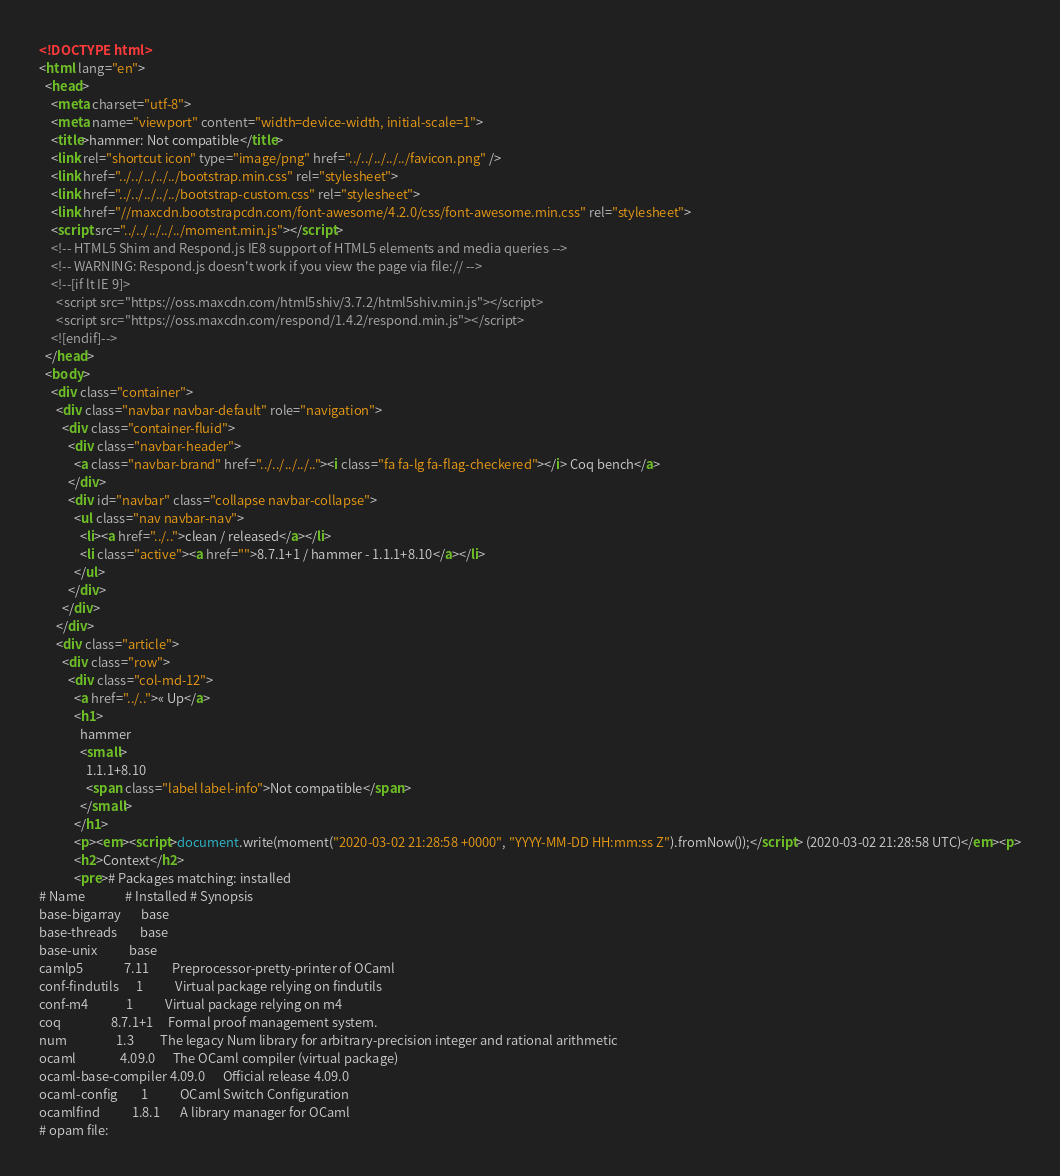<code> <loc_0><loc_0><loc_500><loc_500><_HTML_><!DOCTYPE html>
<html lang="en">
  <head>
    <meta charset="utf-8">
    <meta name="viewport" content="width=device-width, initial-scale=1">
    <title>hammer: Not compatible</title>
    <link rel="shortcut icon" type="image/png" href="../../../../../favicon.png" />
    <link href="../../../../../bootstrap.min.css" rel="stylesheet">
    <link href="../../../../../bootstrap-custom.css" rel="stylesheet">
    <link href="//maxcdn.bootstrapcdn.com/font-awesome/4.2.0/css/font-awesome.min.css" rel="stylesheet">
    <script src="../../../../../moment.min.js"></script>
    <!-- HTML5 Shim and Respond.js IE8 support of HTML5 elements and media queries -->
    <!-- WARNING: Respond.js doesn't work if you view the page via file:// -->
    <!--[if lt IE 9]>
      <script src="https://oss.maxcdn.com/html5shiv/3.7.2/html5shiv.min.js"></script>
      <script src="https://oss.maxcdn.com/respond/1.4.2/respond.min.js"></script>
    <![endif]-->
  </head>
  <body>
    <div class="container">
      <div class="navbar navbar-default" role="navigation">
        <div class="container-fluid">
          <div class="navbar-header">
            <a class="navbar-brand" href="../../../../.."><i class="fa fa-lg fa-flag-checkered"></i> Coq bench</a>
          </div>
          <div id="navbar" class="collapse navbar-collapse">
            <ul class="nav navbar-nav">
              <li><a href="../..">clean / released</a></li>
              <li class="active"><a href="">8.7.1+1 / hammer - 1.1.1+8.10</a></li>
            </ul>
          </div>
        </div>
      </div>
      <div class="article">
        <div class="row">
          <div class="col-md-12">
            <a href="../..">« Up</a>
            <h1>
              hammer
              <small>
                1.1.1+8.10
                <span class="label label-info">Not compatible</span>
              </small>
            </h1>
            <p><em><script>document.write(moment("2020-03-02 21:28:58 +0000", "YYYY-MM-DD HH:mm:ss Z").fromNow());</script> (2020-03-02 21:28:58 UTC)</em><p>
            <h2>Context</h2>
            <pre># Packages matching: installed
# Name              # Installed # Synopsis
base-bigarray       base
base-threads        base
base-unix           base
camlp5              7.11        Preprocessor-pretty-printer of OCaml
conf-findutils      1           Virtual package relying on findutils
conf-m4             1           Virtual package relying on m4
coq                 8.7.1+1     Formal proof management system.
num                 1.3         The legacy Num library for arbitrary-precision integer and rational arithmetic
ocaml               4.09.0      The OCaml compiler (virtual package)
ocaml-base-compiler 4.09.0      Official release 4.09.0
ocaml-config        1           OCaml Switch Configuration
ocamlfind           1.8.1       A library manager for OCaml
# opam file:</code> 